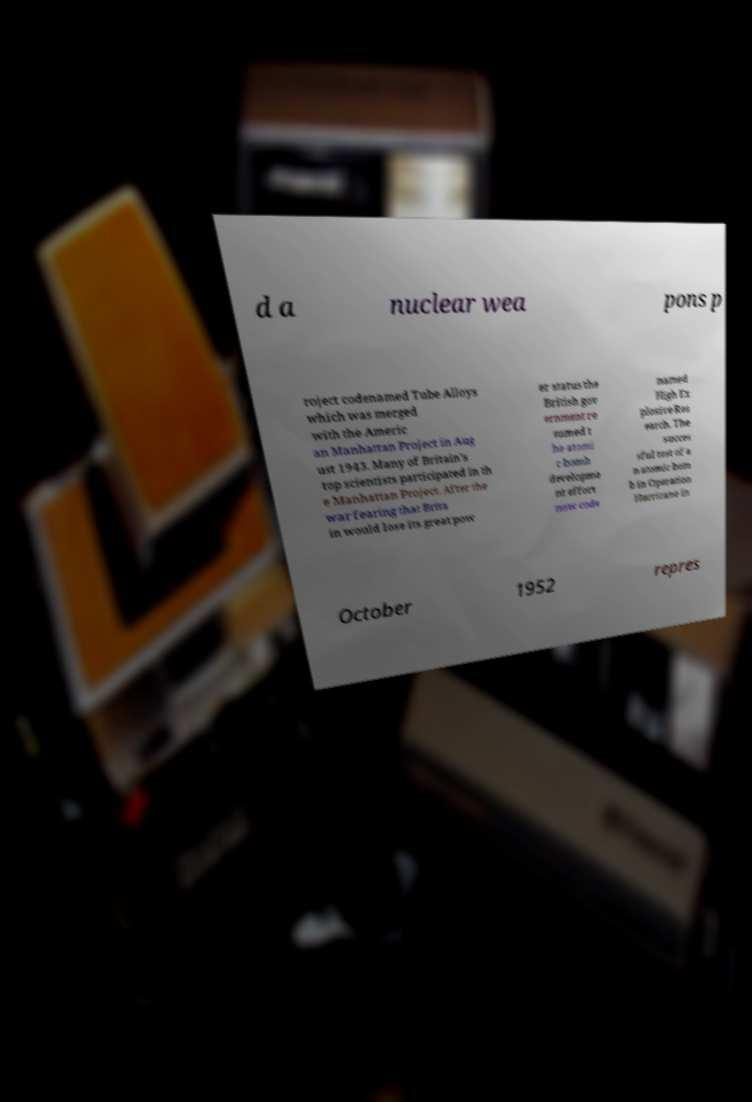Can you read and provide the text displayed in the image?This photo seems to have some interesting text. Can you extract and type it out for me? d a nuclear wea pons p roject codenamed Tube Alloys which was merged with the Americ an Manhattan Project in Aug ust 1943. Many of Britain's top scientists participated in th e Manhattan Project. After the war fearing that Brita in would lose its great pow er status the British gov ernment re sumed t he atomi c bomb developme nt effort now code named High Ex plosive Res earch. The succes sful test of a n atomic bom b in Operation Hurricane in October 1952 repres 